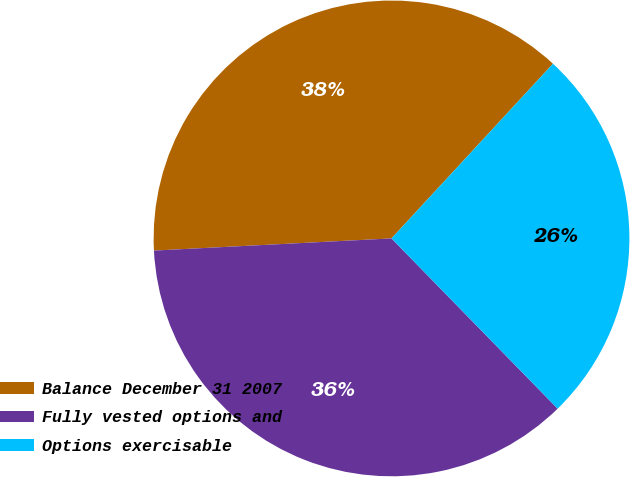Convert chart. <chart><loc_0><loc_0><loc_500><loc_500><pie_chart><fcel>Balance December 31 2007<fcel>Fully vested options and<fcel>Options exercisable<nl><fcel>37.69%<fcel>36.49%<fcel>25.82%<nl></chart> 